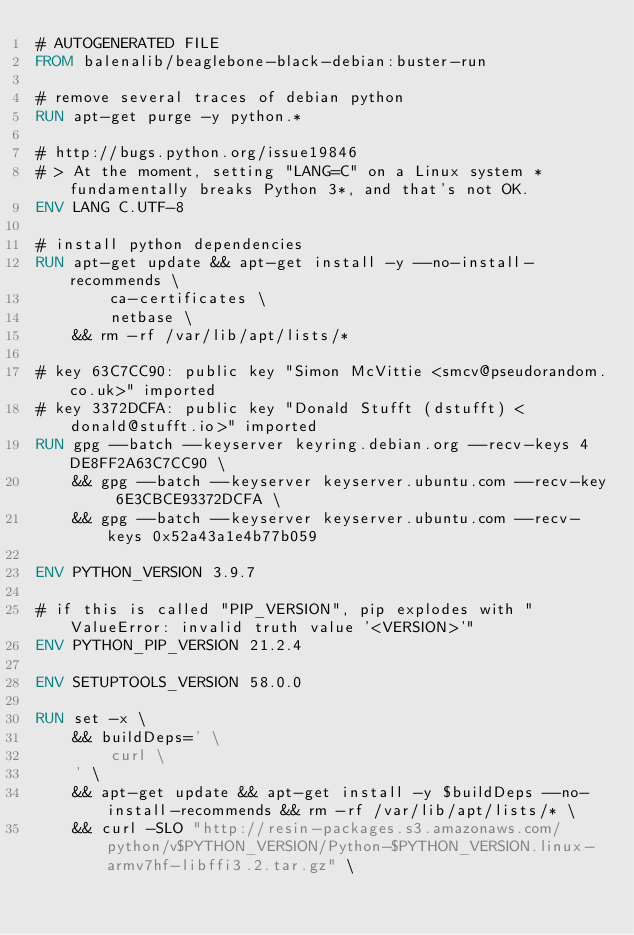Convert code to text. <code><loc_0><loc_0><loc_500><loc_500><_Dockerfile_># AUTOGENERATED FILE
FROM balenalib/beaglebone-black-debian:buster-run

# remove several traces of debian python
RUN apt-get purge -y python.*

# http://bugs.python.org/issue19846
# > At the moment, setting "LANG=C" on a Linux system *fundamentally breaks Python 3*, and that's not OK.
ENV LANG C.UTF-8

# install python dependencies
RUN apt-get update && apt-get install -y --no-install-recommends \
		ca-certificates \
		netbase \
	&& rm -rf /var/lib/apt/lists/*

# key 63C7CC90: public key "Simon McVittie <smcv@pseudorandom.co.uk>" imported
# key 3372DCFA: public key "Donald Stufft (dstufft) <donald@stufft.io>" imported
RUN gpg --batch --keyserver keyring.debian.org --recv-keys 4DE8FF2A63C7CC90 \
	&& gpg --batch --keyserver keyserver.ubuntu.com --recv-key 6E3CBCE93372DCFA \
	&& gpg --batch --keyserver keyserver.ubuntu.com --recv-keys 0x52a43a1e4b77b059

ENV PYTHON_VERSION 3.9.7

# if this is called "PIP_VERSION", pip explodes with "ValueError: invalid truth value '<VERSION>'"
ENV PYTHON_PIP_VERSION 21.2.4

ENV SETUPTOOLS_VERSION 58.0.0

RUN set -x \
	&& buildDeps=' \
		curl \
	' \
	&& apt-get update && apt-get install -y $buildDeps --no-install-recommends && rm -rf /var/lib/apt/lists/* \
	&& curl -SLO "http://resin-packages.s3.amazonaws.com/python/v$PYTHON_VERSION/Python-$PYTHON_VERSION.linux-armv7hf-libffi3.2.tar.gz" \</code> 